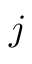<formula> <loc_0><loc_0><loc_500><loc_500>j</formula> 